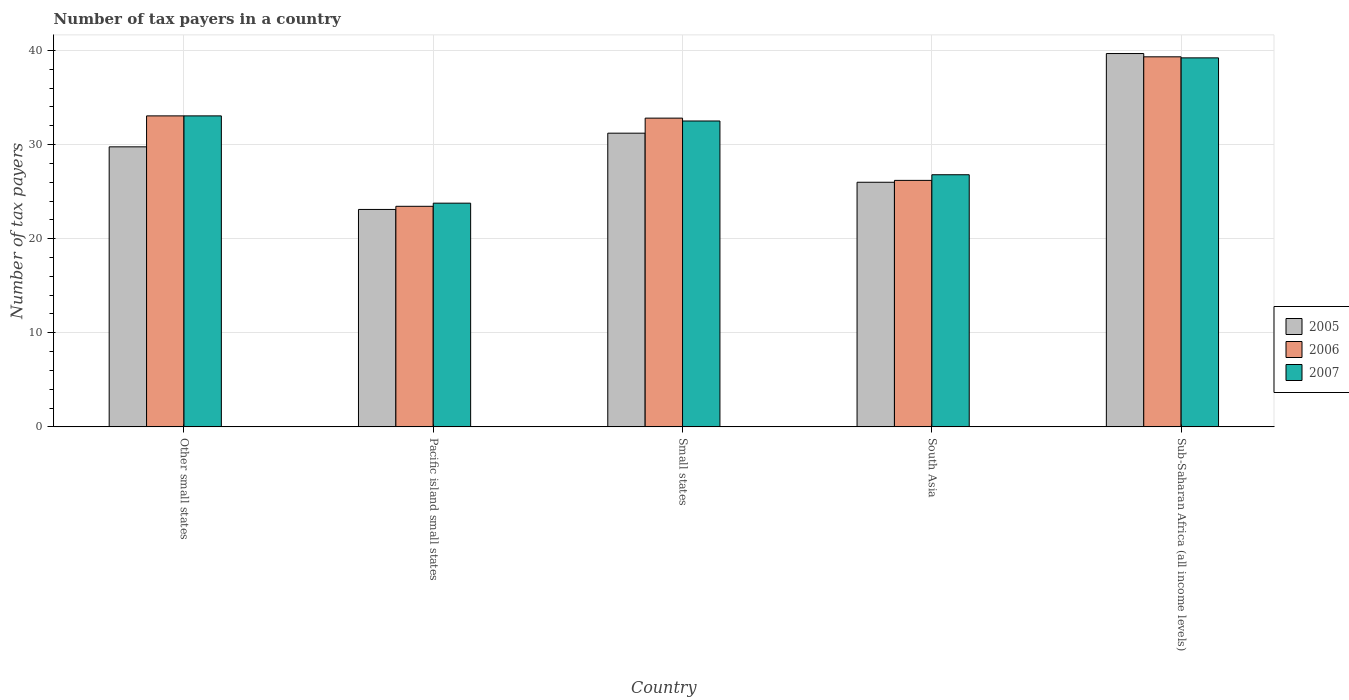Are the number of bars on each tick of the X-axis equal?
Offer a terse response. Yes. How many bars are there on the 3rd tick from the left?
Your response must be concise. 3. In how many cases, is the number of bars for a given country not equal to the number of legend labels?
Your answer should be very brief. 0. What is the number of tax payers in in 2005 in Small states?
Provide a succinct answer. 31.22. Across all countries, what is the maximum number of tax payers in in 2007?
Your answer should be very brief. 39.22. Across all countries, what is the minimum number of tax payers in in 2005?
Offer a very short reply. 23.11. In which country was the number of tax payers in in 2006 maximum?
Your answer should be compact. Sub-Saharan Africa (all income levels). In which country was the number of tax payers in in 2006 minimum?
Keep it short and to the point. Pacific island small states. What is the total number of tax payers in in 2007 in the graph?
Your answer should be compact. 155.37. What is the difference between the number of tax payers in in 2005 in Pacific island small states and that in Small states?
Offer a terse response. -8.11. What is the difference between the number of tax payers in in 2005 in Sub-Saharan Africa (all income levels) and the number of tax payers in in 2007 in Other small states?
Ensure brevity in your answer.  6.63. What is the average number of tax payers in in 2005 per country?
Provide a short and direct response. 29.95. What is the difference between the number of tax payers in of/in 2007 and number of tax payers in of/in 2005 in Other small states?
Your response must be concise. 3.29. In how many countries, is the number of tax payers in in 2007 greater than 10?
Give a very brief answer. 5. What is the ratio of the number of tax payers in in 2007 in Small states to that in South Asia?
Make the answer very short. 1.21. Is the number of tax payers in in 2006 in Pacific island small states less than that in Sub-Saharan Africa (all income levels)?
Make the answer very short. Yes. What is the difference between the highest and the second highest number of tax payers in in 2007?
Offer a terse response. -0.54. What is the difference between the highest and the lowest number of tax payers in in 2006?
Make the answer very short. 15.89. In how many countries, is the number of tax payers in in 2007 greater than the average number of tax payers in in 2007 taken over all countries?
Your answer should be very brief. 3. Is the sum of the number of tax payers in in 2005 in Other small states and Sub-Saharan Africa (all income levels) greater than the maximum number of tax payers in in 2006 across all countries?
Keep it short and to the point. Yes. What does the 1st bar from the right in Other small states represents?
Your answer should be compact. 2007. Is it the case that in every country, the sum of the number of tax payers in in 2005 and number of tax payers in in 2006 is greater than the number of tax payers in in 2007?
Provide a short and direct response. Yes. What is the difference between two consecutive major ticks on the Y-axis?
Ensure brevity in your answer.  10. Does the graph contain grids?
Ensure brevity in your answer.  Yes. Where does the legend appear in the graph?
Your answer should be very brief. Center right. What is the title of the graph?
Your answer should be very brief. Number of tax payers in a country. What is the label or title of the Y-axis?
Provide a succinct answer. Number of tax payers. What is the Number of tax payers in 2005 in Other small states?
Provide a succinct answer. 29.76. What is the Number of tax payers in 2006 in Other small states?
Your answer should be compact. 33.06. What is the Number of tax payers in 2007 in Other small states?
Your answer should be compact. 33.06. What is the Number of tax payers in 2005 in Pacific island small states?
Ensure brevity in your answer.  23.11. What is the Number of tax payers of 2006 in Pacific island small states?
Make the answer very short. 23.44. What is the Number of tax payers of 2007 in Pacific island small states?
Provide a succinct answer. 23.78. What is the Number of tax payers of 2005 in Small states?
Offer a terse response. 31.22. What is the Number of tax payers in 2006 in Small states?
Provide a succinct answer. 32.82. What is the Number of tax payers of 2007 in Small states?
Provide a short and direct response. 32.51. What is the Number of tax payers in 2005 in South Asia?
Make the answer very short. 26. What is the Number of tax payers in 2006 in South Asia?
Provide a succinct answer. 26.2. What is the Number of tax payers of 2007 in South Asia?
Make the answer very short. 26.8. What is the Number of tax payers of 2005 in Sub-Saharan Africa (all income levels)?
Keep it short and to the point. 39.68. What is the Number of tax payers in 2006 in Sub-Saharan Africa (all income levels)?
Offer a very short reply. 39.33. What is the Number of tax payers in 2007 in Sub-Saharan Africa (all income levels)?
Offer a terse response. 39.22. Across all countries, what is the maximum Number of tax payers of 2005?
Give a very brief answer. 39.68. Across all countries, what is the maximum Number of tax payers in 2006?
Offer a terse response. 39.33. Across all countries, what is the maximum Number of tax payers in 2007?
Provide a succinct answer. 39.22. Across all countries, what is the minimum Number of tax payers of 2005?
Keep it short and to the point. 23.11. Across all countries, what is the minimum Number of tax payers in 2006?
Offer a terse response. 23.44. Across all countries, what is the minimum Number of tax payers in 2007?
Offer a very short reply. 23.78. What is the total Number of tax payers of 2005 in the graph?
Offer a terse response. 149.77. What is the total Number of tax payers in 2006 in the graph?
Offer a terse response. 154.85. What is the total Number of tax payers in 2007 in the graph?
Give a very brief answer. 155.37. What is the difference between the Number of tax payers of 2005 in Other small states and that in Pacific island small states?
Offer a very short reply. 6.65. What is the difference between the Number of tax payers of 2006 in Other small states and that in Pacific island small states?
Offer a terse response. 9.61. What is the difference between the Number of tax payers in 2007 in Other small states and that in Pacific island small states?
Keep it short and to the point. 9.28. What is the difference between the Number of tax payers in 2005 in Other small states and that in Small states?
Give a very brief answer. -1.45. What is the difference between the Number of tax payers in 2006 in Other small states and that in Small states?
Provide a short and direct response. 0.24. What is the difference between the Number of tax payers of 2007 in Other small states and that in Small states?
Offer a very short reply. 0.54. What is the difference between the Number of tax payers in 2005 in Other small states and that in South Asia?
Provide a short and direct response. 3.76. What is the difference between the Number of tax payers in 2006 in Other small states and that in South Asia?
Offer a terse response. 6.86. What is the difference between the Number of tax payers in 2007 in Other small states and that in South Asia?
Make the answer very short. 6.26. What is the difference between the Number of tax payers of 2005 in Other small states and that in Sub-Saharan Africa (all income levels)?
Provide a short and direct response. -9.92. What is the difference between the Number of tax payers in 2006 in Other small states and that in Sub-Saharan Africa (all income levels)?
Your response must be concise. -6.28. What is the difference between the Number of tax payers in 2007 in Other small states and that in Sub-Saharan Africa (all income levels)?
Keep it short and to the point. -6.17. What is the difference between the Number of tax payers in 2005 in Pacific island small states and that in Small states?
Provide a short and direct response. -8.11. What is the difference between the Number of tax payers in 2006 in Pacific island small states and that in Small states?
Keep it short and to the point. -9.37. What is the difference between the Number of tax payers in 2007 in Pacific island small states and that in Small states?
Your answer should be compact. -8.73. What is the difference between the Number of tax payers in 2005 in Pacific island small states and that in South Asia?
Ensure brevity in your answer.  -2.89. What is the difference between the Number of tax payers of 2006 in Pacific island small states and that in South Asia?
Offer a very short reply. -2.76. What is the difference between the Number of tax payers in 2007 in Pacific island small states and that in South Asia?
Your answer should be compact. -3.02. What is the difference between the Number of tax payers of 2005 in Pacific island small states and that in Sub-Saharan Africa (all income levels)?
Give a very brief answer. -16.57. What is the difference between the Number of tax payers in 2006 in Pacific island small states and that in Sub-Saharan Africa (all income levels)?
Ensure brevity in your answer.  -15.89. What is the difference between the Number of tax payers in 2007 in Pacific island small states and that in Sub-Saharan Africa (all income levels)?
Your answer should be compact. -15.44. What is the difference between the Number of tax payers of 2005 in Small states and that in South Asia?
Provide a short and direct response. 5.22. What is the difference between the Number of tax payers of 2006 in Small states and that in South Asia?
Your answer should be compact. 6.62. What is the difference between the Number of tax payers of 2007 in Small states and that in South Asia?
Offer a terse response. 5.71. What is the difference between the Number of tax payers of 2005 in Small states and that in Sub-Saharan Africa (all income levels)?
Your answer should be very brief. -8.47. What is the difference between the Number of tax payers of 2006 in Small states and that in Sub-Saharan Africa (all income levels)?
Your answer should be very brief. -6.52. What is the difference between the Number of tax payers of 2007 in Small states and that in Sub-Saharan Africa (all income levels)?
Keep it short and to the point. -6.71. What is the difference between the Number of tax payers of 2005 in South Asia and that in Sub-Saharan Africa (all income levels)?
Provide a short and direct response. -13.68. What is the difference between the Number of tax payers of 2006 in South Asia and that in Sub-Saharan Africa (all income levels)?
Keep it short and to the point. -13.13. What is the difference between the Number of tax payers of 2007 in South Asia and that in Sub-Saharan Africa (all income levels)?
Your answer should be compact. -12.42. What is the difference between the Number of tax payers in 2005 in Other small states and the Number of tax payers in 2006 in Pacific island small states?
Your response must be concise. 6.32. What is the difference between the Number of tax payers of 2005 in Other small states and the Number of tax payers of 2007 in Pacific island small states?
Give a very brief answer. 5.99. What is the difference between the Number of tax payers in 2006 in Other small states and the Number of tax payers in 2007 in Pacific island small states?
Your answer should be compact. 9.28. What is the difference between the Number of tax payers in 2005 in Other small states and the Number of tax payers in 2006 in Small states?
Your answer should be very brief. -3.05. What is the difference between the Number of tax payers of 2005 in Other small states and the Number of tax payers of 2007 in Small states?
Ensure brevity in your answer.  -2.75. What is the difference between the Number of tax payers of 2006 in Other small states and the Number of tax payers of 2007 in Small states?
Provide a succinct answer. 0.54. What is the difference between the Number of tax payers in 2005 in Other small states and the Number of tax payers in 2006 in South Asia?
Your answer should be very brief. 3.56. What is the difference between the Number of tax payers of 2005 in Other small states and the Number of tax payers of 2007 in South Asia?
Your answer should be very brief. 2.96. What is the difference between the Number of tax payers in 2006 in Other small states and the Number of tax payers in 2007 in South Asia?
Provide a succinct answer. 6.26. What is the difference between the Number of tax payers in 2005 in Other small states and the Number of tax payers in 2006 in Sub-Saharan Africa (all income levels)?
Offer a very short reply. -9.57. What is the difference between the Number of tax payers in 2005 in Other small states and the Number of tax payers in 2007 in Sub-Saharan Africa (all income levels)?
Provide a short and direct response. -9.46. What is the difference between the Number of tax payers in 2006 in Other small states and the Number of tax payers in 2007 in Sub-Saharan Africa (all income levels)?
Offer a terse response. -6.17. What is the difference between the Number of tax payers of 2005 in Pacific island small states and the Number of tax payers of 2006 in Small states?
Keep it short and to the point. -9.7. What is the difference between the Number of tax payers in 2005 in Pacific island small states and the Number of tax payers in 2007 in Small states?
Keep it short and to the point. -9.4. What is the difference between the Number of tax payers of 2006 in Pacific island small states and the Number of tax payers of 2007 in Small states?
Keep it short and to the point. -9.07. What is the difference between the Number of tax payers in 2005 in Pacific island small states and the Number of tax payers in 2006 in South Asia?
Your answer should be very brief. -3.09. What is the difference between the Number of tax payers in 2005 in Pacific island small states and the Number of tax payers in 2007 in South Asia?
Make the answer very short. -3.69. What is the difference between the Number of tax payers of 2006 in Pacific island small states and the Number of tax payers of 2007 in South Asia?
Provide a succinct answer. -3.36. What is the difference between the Number of tax payers of 2005 in Pacific island small states and the Number of tax payers of 2006 in Sub-Saharan Africa (all income levels)?
Offer a very short reply. -16.22. What is the difference between the Number of tax payers in 2005 in Pacific island small states and the Number of tax payers in 2007 in Sub-Saharan Africa (all income levels)?
Keep it short and to the point. -16.11. What is the difference between the Number of tax payers in 2006 in Pacific island small states and the Number of tax payers in 2007 in Sub-Saharan Africa (all income levels)?
Offer a very short reply. -15.78. What is the difference between the Number of tax payers in 2005 in Small states and the Number of tax payers in 2006 in South Asia?
Make the answer very short. 5.02. What is the difference between the Number of tax payers of 2005 in Small states and the Number of tax payers of 2007 in South Asia?
Provide a short and direct response. 4.42. What is the difference between the Number of tax payers in 2006 in Small states and the Number of tax payers in 2007 in South Asia?
Offer a very short reply. 6.02. What is the difference between the Number of tax payers in 2005 in Small states and the Number of tax payers in 2006 in Sub-Saharan Africa (all income levels)?
Make the answer very short. -8.12. What is the difference between the Number of tax payers in 2005 in Small states and the Number of tax payers in 2007 in Sub-Saharan Africa (all income levels)?
Your answer should be compact. -8.01. What is the difference between the Number of tax payers in 2006 in Small states and the Number of tax payers in 2007 in Sub-Saharan Africa (all income levels)?
Provide a succinct answer. -6.41. What is the difference between the Number of tax payers of 2005 in South Asia and the Number of tax payers of 2006 in Sub-Saharan Africa (all income levels)?
Keep it short and to the point. -13.33. What is the difference between the Number of tax payers of 2005 in South Asia and the Number of tax payers of 2007 in Sub-Saharan Africa (all income levels)?
Ensure brevity in your answer.  -13.22. What is the difference between the Number of tax payers of 2006 in South Asia and the Number of tax payers of 2007 in Sub-Saharan Africa (all income levels)?
Give a very brief answer. -13.02. What is the average Number of tax payers of 2005 per country?
Ensure brevity in your answer.  29.95. What is the average Number of tax payers in 2006 per country?
Offer a very short reply. 30.97. What is the average Number of tax payers in 2007 per country?
Provide a short and direct response. 31.07. What is the difference between the Number of tax payers in 2005 and Number of tax payers in 2006 in Other small states?
Ensure brevity in your answer.  -3.29. What is the difference between the Number of tax payers of 2005 and Number of tax payers of 2007 in Other small states?
Offer a terse response. -3.29. What is the difference between the Number of tax payers in 2006 and Number of tax payers in 2007 in Other small states?
Give a very brief answer. 0. What is the difference between the Number of tax payers of 2006 and Number of tax payers of 2007 in Pacific island small states?
Your answer should be compact. -0.33. What is the difference between the Number of tax payers in 2005 and Number of tax payers in 2006 in Small states?
Your response must be concise. -1.6. What is the difference between the Number of tax payers of 2005 and Number of tax payers of 2007 in Small states?
Offer a terse response. -1.3. What is the difference between the Number of tax payers of 2006 and Number of tax payers of 2007 in Small states?
Keep it short and to the point. 0.3. What is the difference between the Number of tax payers of 2005 and Number of tax payers of 2006 in South Asia?
Provide a short and direct response. -0.2. What is the difference between the Number of tax payers in 2006 and Number of tax payers in 2007 in South Asia?
Your response must be concise. -0.6. What is the difference between the Number of tax payers of 2005 and Number of tax payers of 2006 in Sub-Saharan Africa (all income levels)?
Your answer should be compact. 0.35. What is the difference between the Number of tax payers in 2005 and Number of tax payers in 2007 in Sub-Saharan Africa (all income levels)?
Your answer should be compact. 0.46. What is the difference between the Number of tax payers of 2006 and Number of tax payers of 2007 in Sub-Saharan Africa (all income levels)?
Your response must be concise. 0.11. What is the ratio of the Number of tax payers in 2005 in Other small states to that in Pacific island small states?
Provide a short and direct response. 1.29. What is the ratio of the Number of tax payers in 2006 in Other small states to that in Pacific island small states?
Keep it short and to the point. 1.41. What is the ratio of the Number of tax payers of 2007 in Other small states to that in Pacific island small states?
Provide a short and direct response. 1.39. What is the ratio of the Number of tax payers in 2005 in Other small states to that in Small states?
Your answer should be very brief. 0.95. What is the ratio of the Number of tax payers of 2006 in Other small states to that in Small states?
Offer a very short reply. 1.01. What is the ratio of the Number of tax payers in 2007 in Other small states to that in Small states?
Make the answer very short. 1.02. What is the ratio of the Number of tax payers in 2005 in Other small states to that in South Asia?
Make the answer very short. 1.14. What is the ratio of the Number of tax payers of 2006 in Other small states to that in South Asia?
Ensure brevity in your answer.  1.26. What is the ratio of the Number of tax payers in 2007 in Other small states to that in South Asia?
Make the answer very short. 1.23. What is the ratio of the Number of tax payers of 2005 in Other small states to that in Sub-Saharan Africa (all income levels)?
Ensure brevity in your answer.  0.75. What is the ratio of the Number of tax payers of 2006 in Other small states to that in Sub-Saharan Africa (all income levels)?
Give a very brief answer. 0.84. What is the ratio of the Number of tax payers of 2007 in Other small states to that in Sub-Saharan Africa (all income levels)?
Your response must be concise. 0.84. What is the ratio of the Number of tax payers of 2005 in Pacific island small states to that in Small states?
Give a very brief answer. 0.74. What is the ratio of the Number of tax payers in 2006 in Pacific island small states to that in Small states?
Ensure brevity in your answer.  0.71. What is the ratio of the Number of tax payers in 2007 in Pacific island small states to that in Small states?
Make the answer very short. 0.73. What is the ratio of the Number of tax payers in 2005 in Pacific island small states to that in South Asia?
Provide a succinct answer. 0.89. What is the ratio of the Number of tax payers in 2006 in Pacific island small states to that in South Asia?
Offer a very short reply. 0.89. What is the ratio of the Number of tax payers of 2007 in Pacific island small states to that in South Asia?
Ensure brevity in your answer.  0.89. What is the ratio of the Number of tax payers in 2005 in Pacific island small states to that in Sub-Saharan Africa (all income levels)?
Your response must be concise. 0.58. What is the ratio of the Number of tax payers in 2006 in Pacific island small states to that in Sub-Saharan Africa (all income levels)?
Ensure brevity in your answer.  0.6. What is the ratio of the Number of tax payers in 2007 in Pacific island small states to that in Sub-Saharan Africa (all income levels)?
Your answer should be compact. 0.61. What is the ratio of the Number of tax payers of 2005 in Small states to that in South Asia?
Give a very brief answer. 1.2. What is the ratio of the Number of tax payers of 2006 in Small states to that in South Asia?
Your answer should be very brief. 1.25. What is the ratio of the Number of tax payers of 2007 in Small states to that in South Asia?
Keep it short and to the point. 1.21. What is the ratio of the Number of tax payers in 2005 in Small states to that in Sub-Saharan Africa (all income levels)?
Keep it short and to the point. 0.79. What is the ratio of the Number of tax payers of 2006 in Small states to that in Sub-Saharan Africa (all income levels)?
Offer a terse response. 0.83. What is the ratio of the Number of tax payers of 2007 in Small states to that in Sub-Saharan Africa (all income levels)?
Your answer should be compact. 0.83. What is the ratio of the Number of tax payers in 2005 in South Asia to that in Sub-Saharan Africa (all income levels)?
Provide a short and direct response. 0.66. What is the ratio of the Number of tax payers of 2006 in South Asia to that in Sub-Saharan Africa (all income levels)?
Keep it short and to the point. 0.67. What is the ratio of the Number of tax payers in 2007 in South Asia to that in Sub-Saharan Africa (all income levels)?
Give a very brief answer. 0.68. What is the difference between the highest and the second highest Number of tax payers of 2005?
Offer a very short reply. 8.47. What is the difference between the highest and the second highest Number of tax payers in 2006?
Your answer should be compact. 6.28. What is the difference between the highest and the second highest Number of tax payers in 2007?
Your answer should be very brief. 6.17. What is the difference between the highest and the lowest Number of tax payers in 2005?
Offer a very short reply. 16.57. What is the difference between the highest and the lowest Number of tax payers of 2006?
Ensure brevity in your answer.  15.89. What is the difference between the highest and the lowest Number of tax payers of 2007?
Provide a short and direct response. 15.44. 